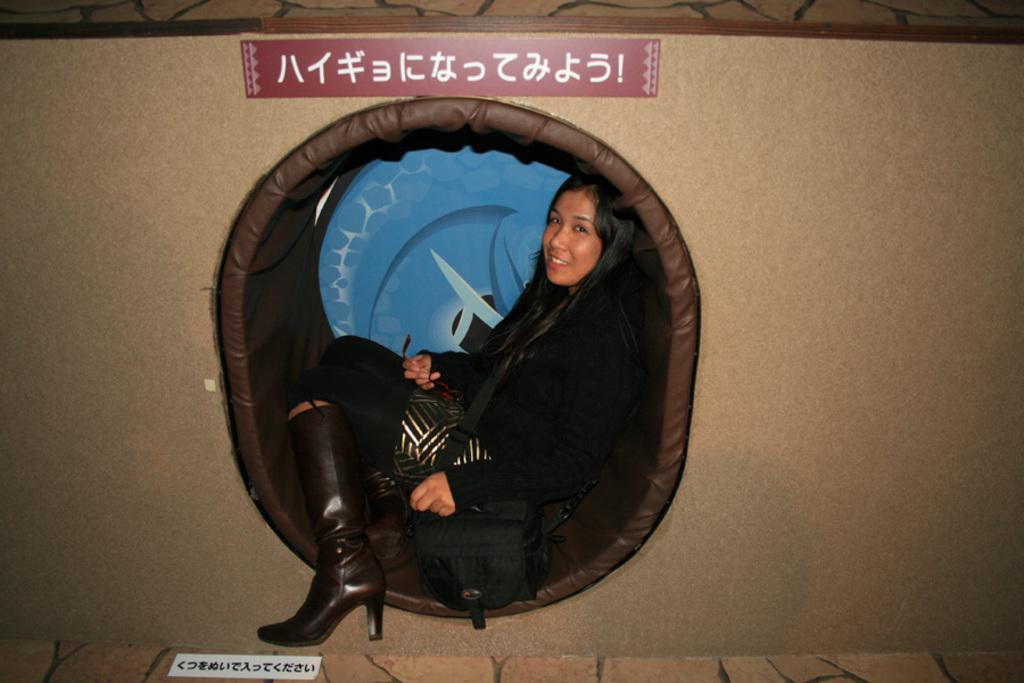Who is present in the image? There is a woman in the image. What is the woman doing in the image? The woman is sitting. How does the woman appear to be feeling in the image? The woman has a smile on her face, suggesting she is happy or content. What can be seen in the background of the image? There is a wall in the image. Can you see any planes flying in the image? There are no planes visible in the image. Is the woman in the image a minister? There is no indication in the image that the woman is a minister. Are there any dinosaurs present in the image? There are no dinosaurs present in the image. 